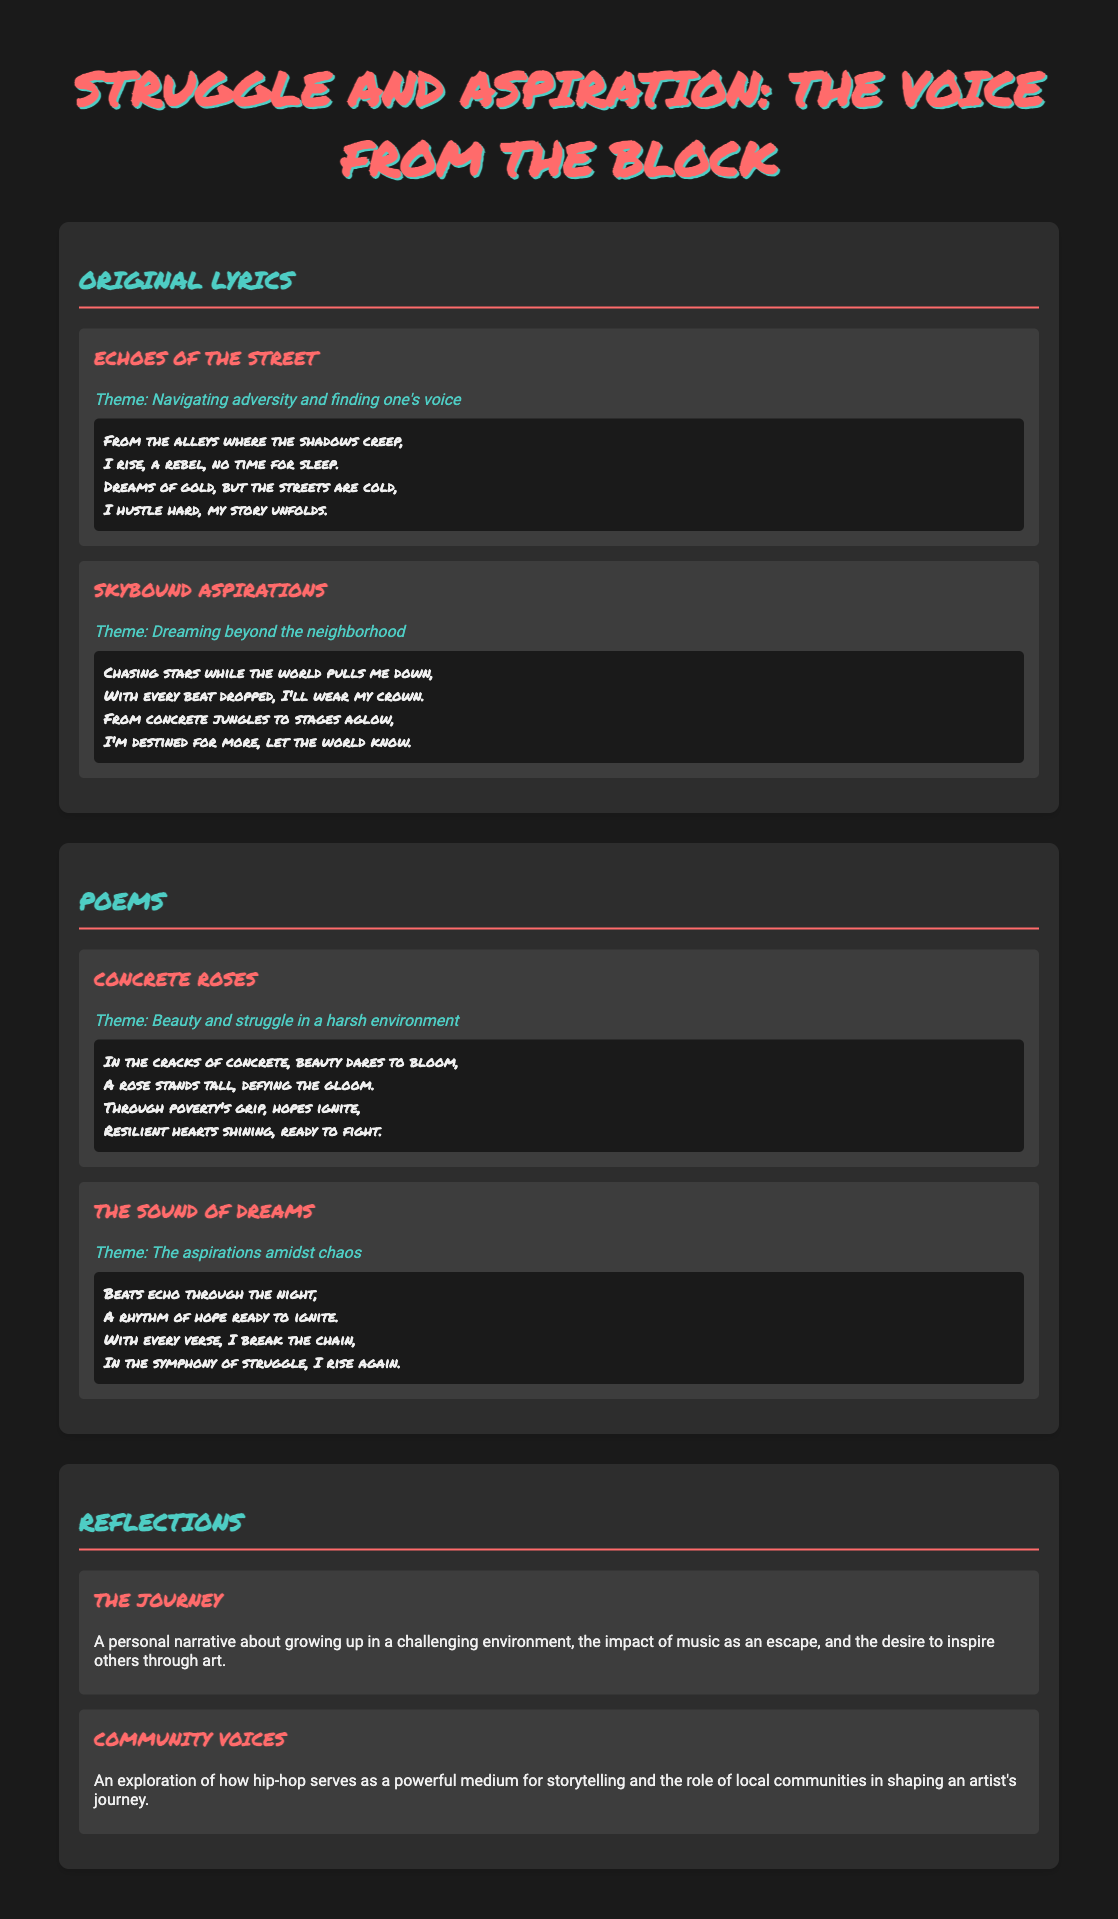What is the title of the document? The title of the document is provided at the top of the page, which is "Struggle and Aspiration: The Voice from the Block."
Answer: Struggle and Aspiration: The Voice from the Block How many original lyrics are featured? The document includes a section titled "Original Lyrics," which lists two original lyrics.
Answer: 2 What is the theme of the poem "Concrete Roses"? The document provides a theme for each content item, and "Concrete Roses" is about beauty and struggle in a harsh environment.
Answer: Beauty and struggle in a harsh environment Which content item discusses personal narratives? The document lists a content item under "Reflections" that focuses on personal narratives, specifically "The Journey."
Answer: The Journey What is the theme of "Skybound Aspirations"? The theme for "Skybound Aspirations" is mentioned, focusing on dreaming beyond the neighborhood.
Answer: Dreaming beyond the neighborhood What type of artistic medium does "Community Voices" explore? The document indicates that "Community Voices" explores hip-hop as a powerful medium for storytelling.
Answer: Hip-hop How are the original lyrics formatted? The original lyrics are presented in a content item format, featuring a title, theme, and a snippet of the lyrics.
Answer: Snippet of the lyrics What color is used for the section headings? The section headings are styled in a specific color as indicated in the document, which is #4ecdc4.
Answer: #4ecdc4 